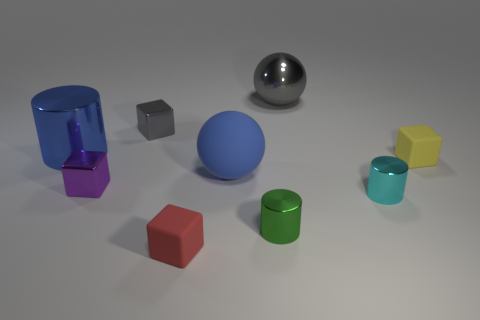The metallic cylinder that is the same color as the matte sphere is what size?
Make the answer very short. Large. The shiny thing that is the same color as the big rubber ball is what shape?
Keep it short and to the point. Cylinder. What is the shape of the tiny rubber object in front of the yellow thing?
Your answer should be very brief. Cube. The large ball that is on the left side of the cylinder that is in front of the cyan thing is what color?
Make the answer very short. Blue. Does the matte object that is left of the blue matte thing have the same shape as the blue thing that is on the right side of the tiny red matte cube?
Offer a very short reply. No. What shape is the purple metallic thing that is the same size as the cyan cylinder?
Offer a very short reply. Cube. What is the color of the ball that is the same material as the yellow object?
Your response must be concise. Blue. Do the yellow thing and the matte object that is in front of the small green shiny object have the same shape?
Give a very brief answer. Yes. What material is the other large object that is the same color as the big rubber thing?
Offer a terse response. Metal. What material is the blue cylinder that is the same size as the matte sphere?
Keep it short and to the point. Metal. 